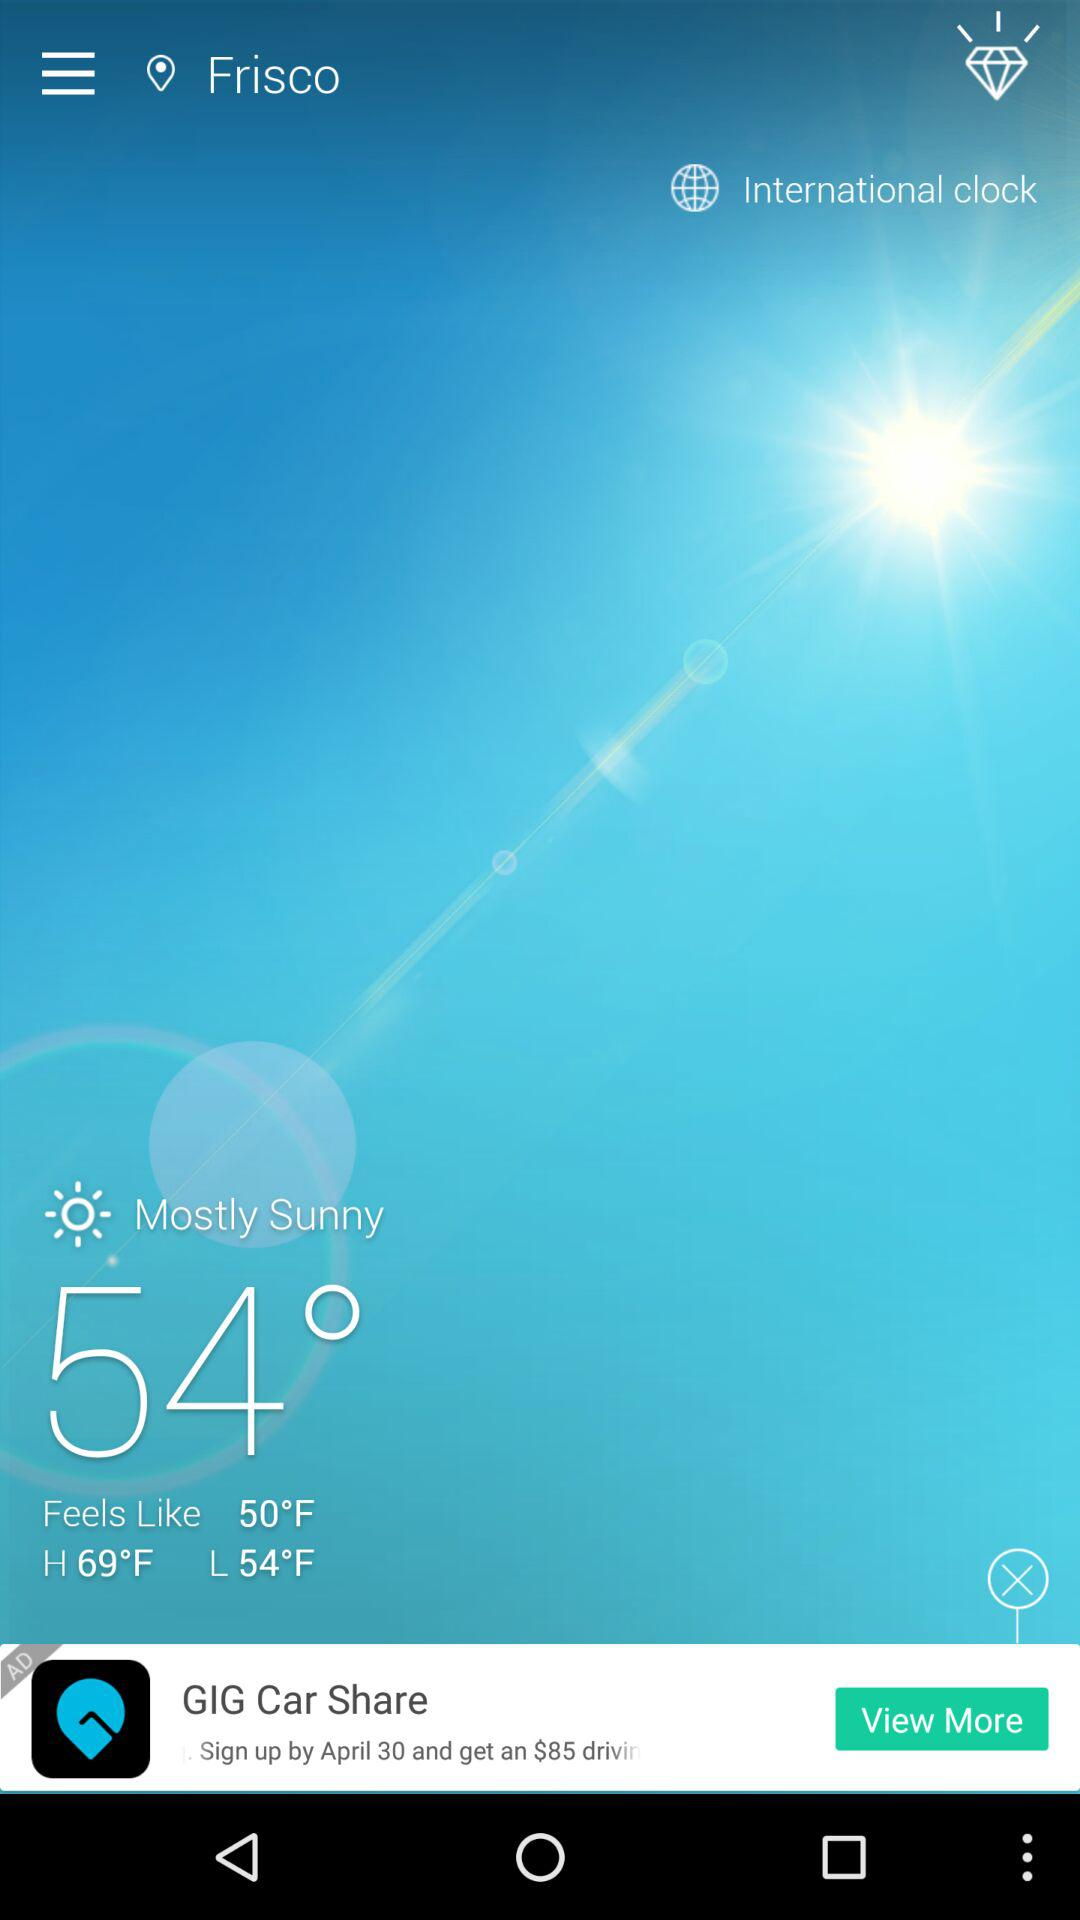What is the temperature in Frisco? The temperature is 54°. 